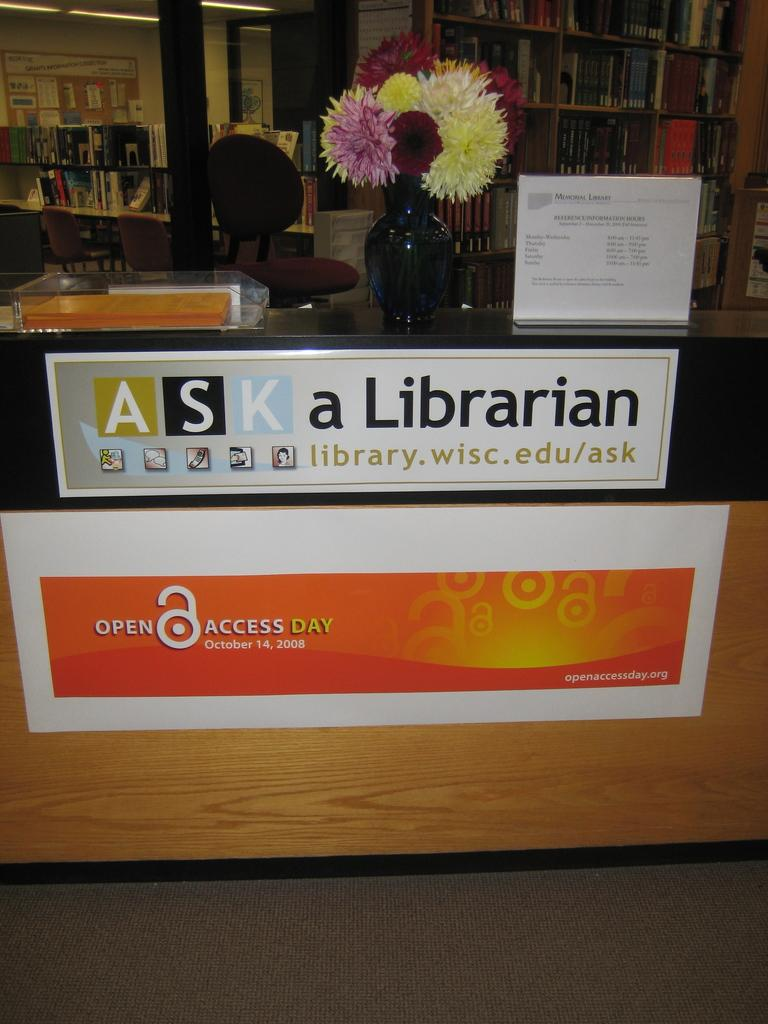<image>
Relay a brief, clear account of the picture shown. a desk at a library suggest asking a librarian on open access day 